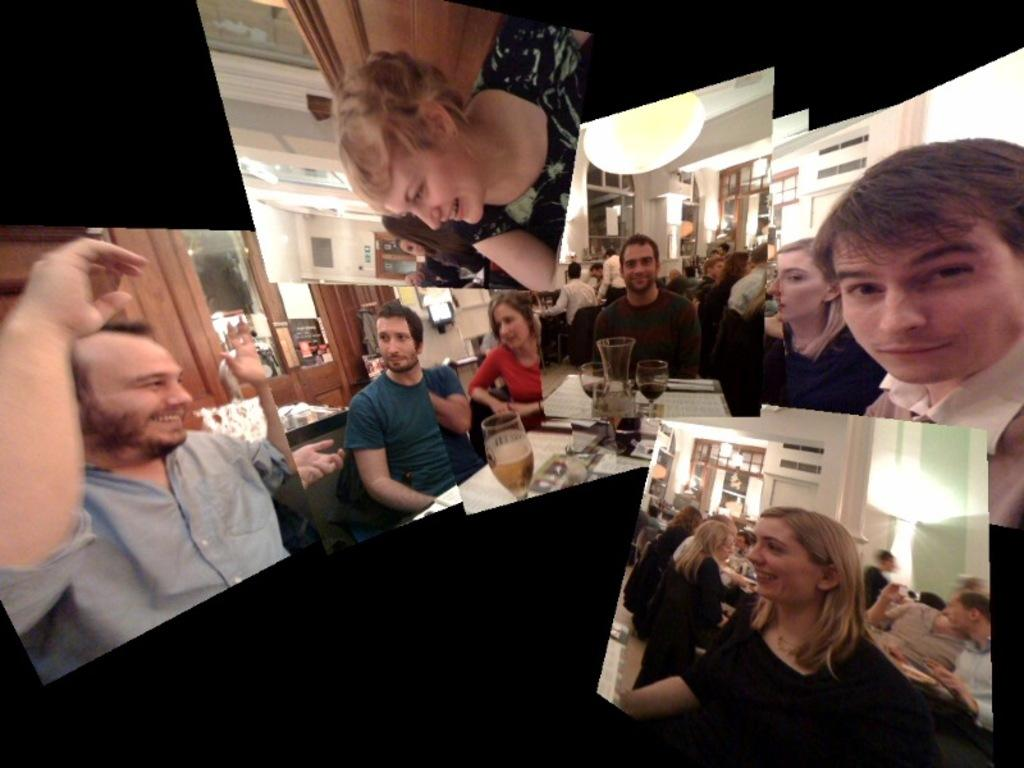How many people are in the image? There are persons in the image, but the exact number is not specified. What objects can be seen in the image related to beverages? There are bottles and glasses in the image. What type of furniture is present in the image? There are tables and cupboards in the image. What lighting is visible in the image? There are lights in the image. What architectural features can be seen in the image? There is a door and a wall in the image. What is the color of the background in the image? The background of the image is black. Can you tell me how many pages are in the notebook in the image? There is no notebook present in the image. What type of guide is leading the group of people in the image? There are no people or guides present in the image. 